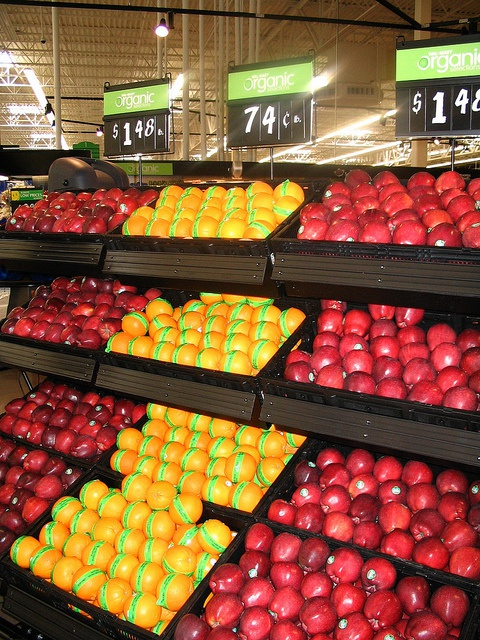Describe the objects in this image and their specific colors. I can see orange in black, orange, gold, and lightgreen tones, apple in black, brown, salmon, and maroon tones, apple in black, brown, and maroon tones, apple in black, brown, and salmon tones, and apple in black, brown, red, and salmon tones in this image. 